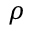<formula> <loc_0><loc_0><loc_500><loc_500>\rho</formula> 